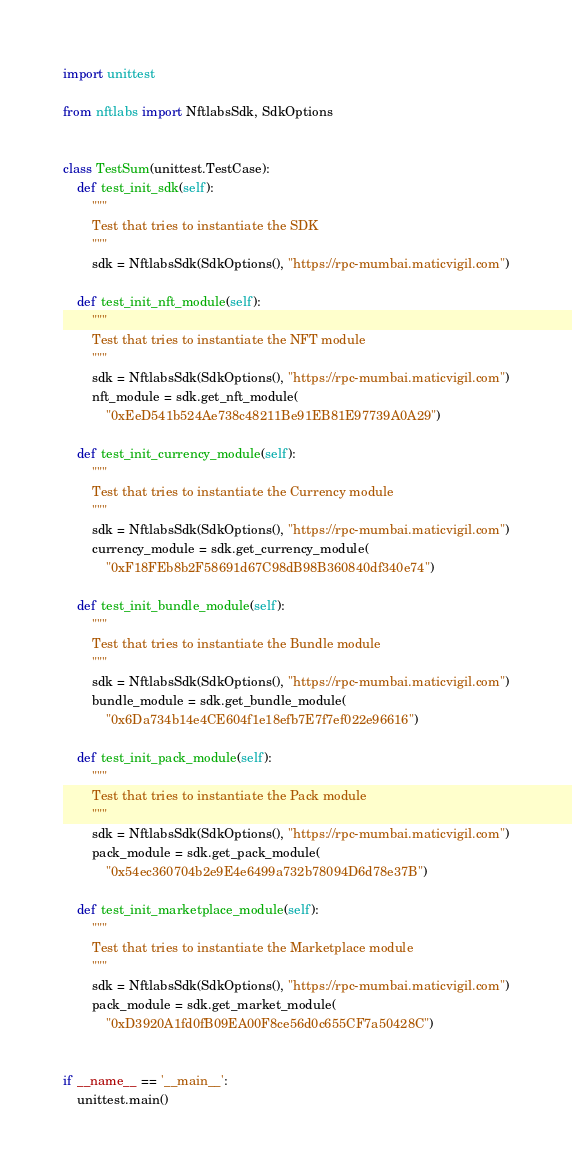Convert code to text. <code><loc_0><loc_0><loc_500><loc_500><_Python_>import unittest

from nftlabs import NftlabsSdk, SdkOptions


class TestSum(unittest.TestCase):
    def test_init_sdk(self):
        """
        Test that tries to instantiate the SDK
        """
        sdk = NftlabsSdk(SdkOptions(), "https://rpc-mumbai.maticvigil.com")

    def test_init_nft_module(self):
        """
        Test that tries to instantiate the NFT module
        """
        sdk = NftlabsSdk(SdkOptions(), "https://rpc-mumbai.maticvigil.com")
        nft_module = sdk.get_nft_module(
            "0xEeD541b524Ae738c48211Be91EB81E97739A0A29")

    def test_init_currency_module(self):
        """
        Test that tries to instantiate the Currency module
        """
        sdk = NftlabsSdk(SdkOptions(), "https://rpc-mumbai.maticvigil.com")
        currency_module = sdk.get_currency_module(
            "0xF18FEb8b2F58691d67C98dB98B360840df340e74")

    def test_init_bundle_module(self):
        """
        Test that tries to instantiate the Bundle module
        """
        sdk = NftlabsSdk(SdkOptions(), "https://rpc-mumbai.maticvigil.com")
        bundle_module = sdk.get_bundle_module(
            "0x6Da734b14e4CE604f1e18efb7E7f7ef022e96616")

    def test_init_pack_module(self):
        """
        Test that tries to instantiate the Pack module
        """
        sdk = NftlabsSdk(SdkOptions(), "https://rpc-mumbai.maticvigil.com")
        pack_module = sdk.get_pack_module(
            "0x54ec360704b2e9E4e6499a732b78094D6d78e37B")

    def test_init_marketplace_module(self):
        """
        Test that tries to instantiate the Marketplace module
        """
        sdk = NftlabsSdk(SdkOptions(), "https://rpc-mumbai.maticvigil.com")
        pack_module = sdk.get_market_module(
            "0xD3920A1fd0fB09EA00F8ce56d0c655CF7a50428C")


if __name__ == '__main__':
    unittest.main()
</code> 